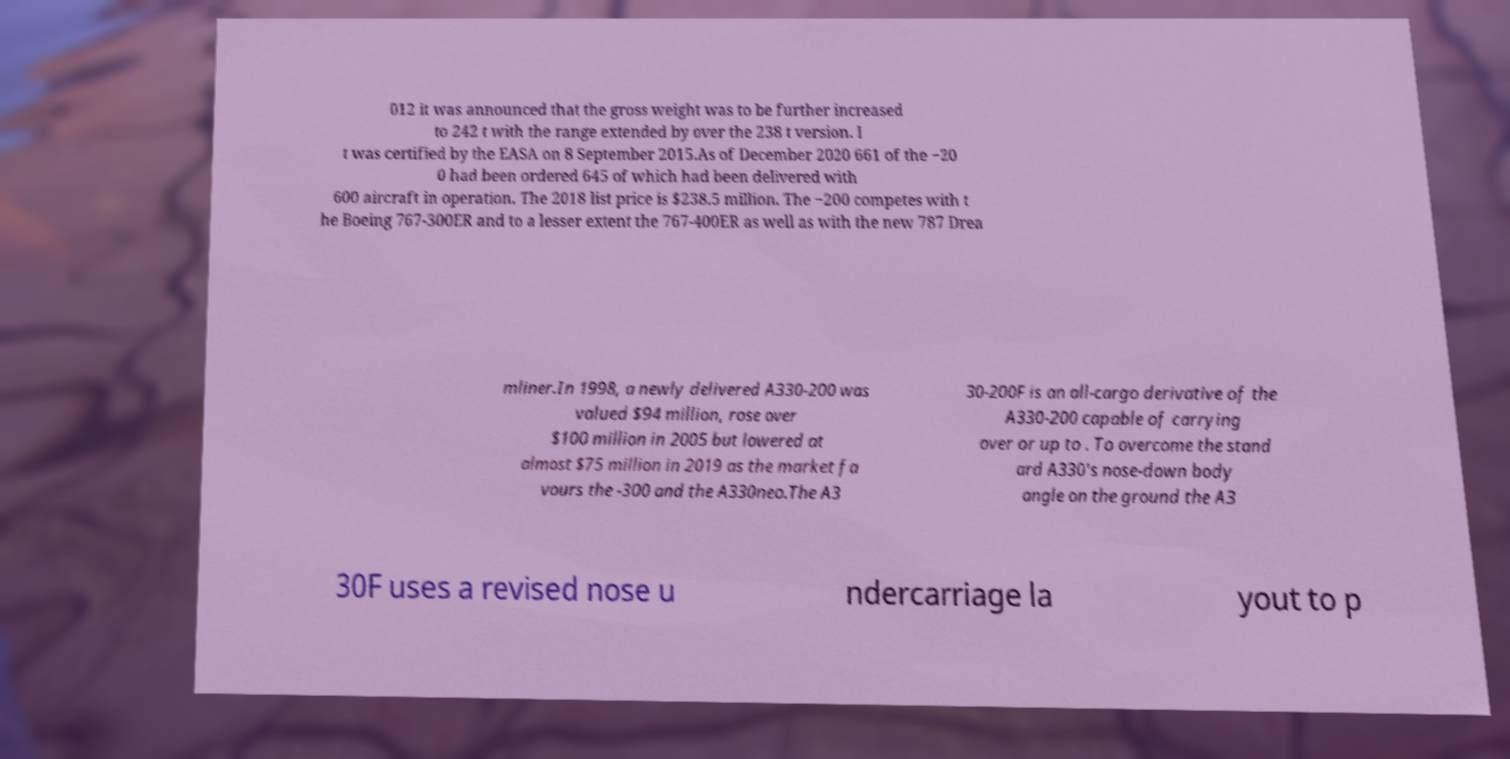Please identify and transcribe the text found in this image. 012 it was announced that the gross weight was to be further increased to 242 t with the range extended by over the 238 t version. I t was certified by the EASA on 8 September 2015.As of December 2020 661 of the −20 0 had been ordered 645 of which had been delivered with 600 aircraft in operation. The 2018 list price is $238.5 million. The −200 competes with t he Boeing 767-300ER and to a lesser extent the 767-400ER as well as with the new 787 Drea mliner.In 1998, a newly delivered A330-200 was valued $94 million, rose over $100 million in 2005 but lowered at almost $75 million in 2019 as the market fa vours the -300 and the A330neo.The A3 30-200F is an all-cargo derivative of the A330-200 capable of carrying over or up to . To overcome the stand ard A330's nose-down body angle on the ground the A3 30F uses a revised nose u ndercarriage la yout to p 